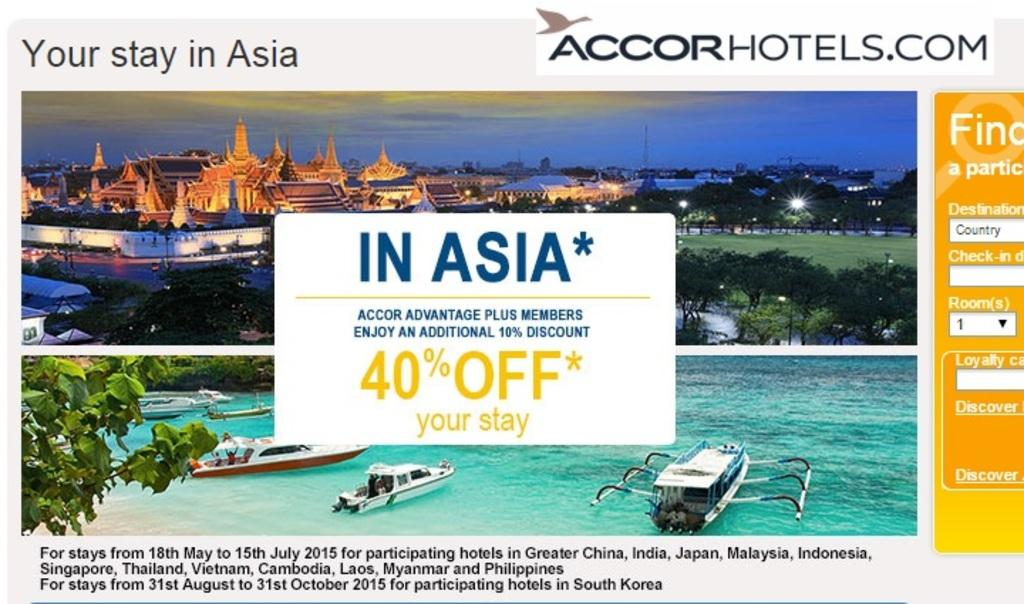What is the main object in the image? There is a display screen in the image. What can be seen on the display screen? There is text visible on the display screen. What type of spring can be seen in the image? There is no spring present in the image; it only features a display screen with text. 